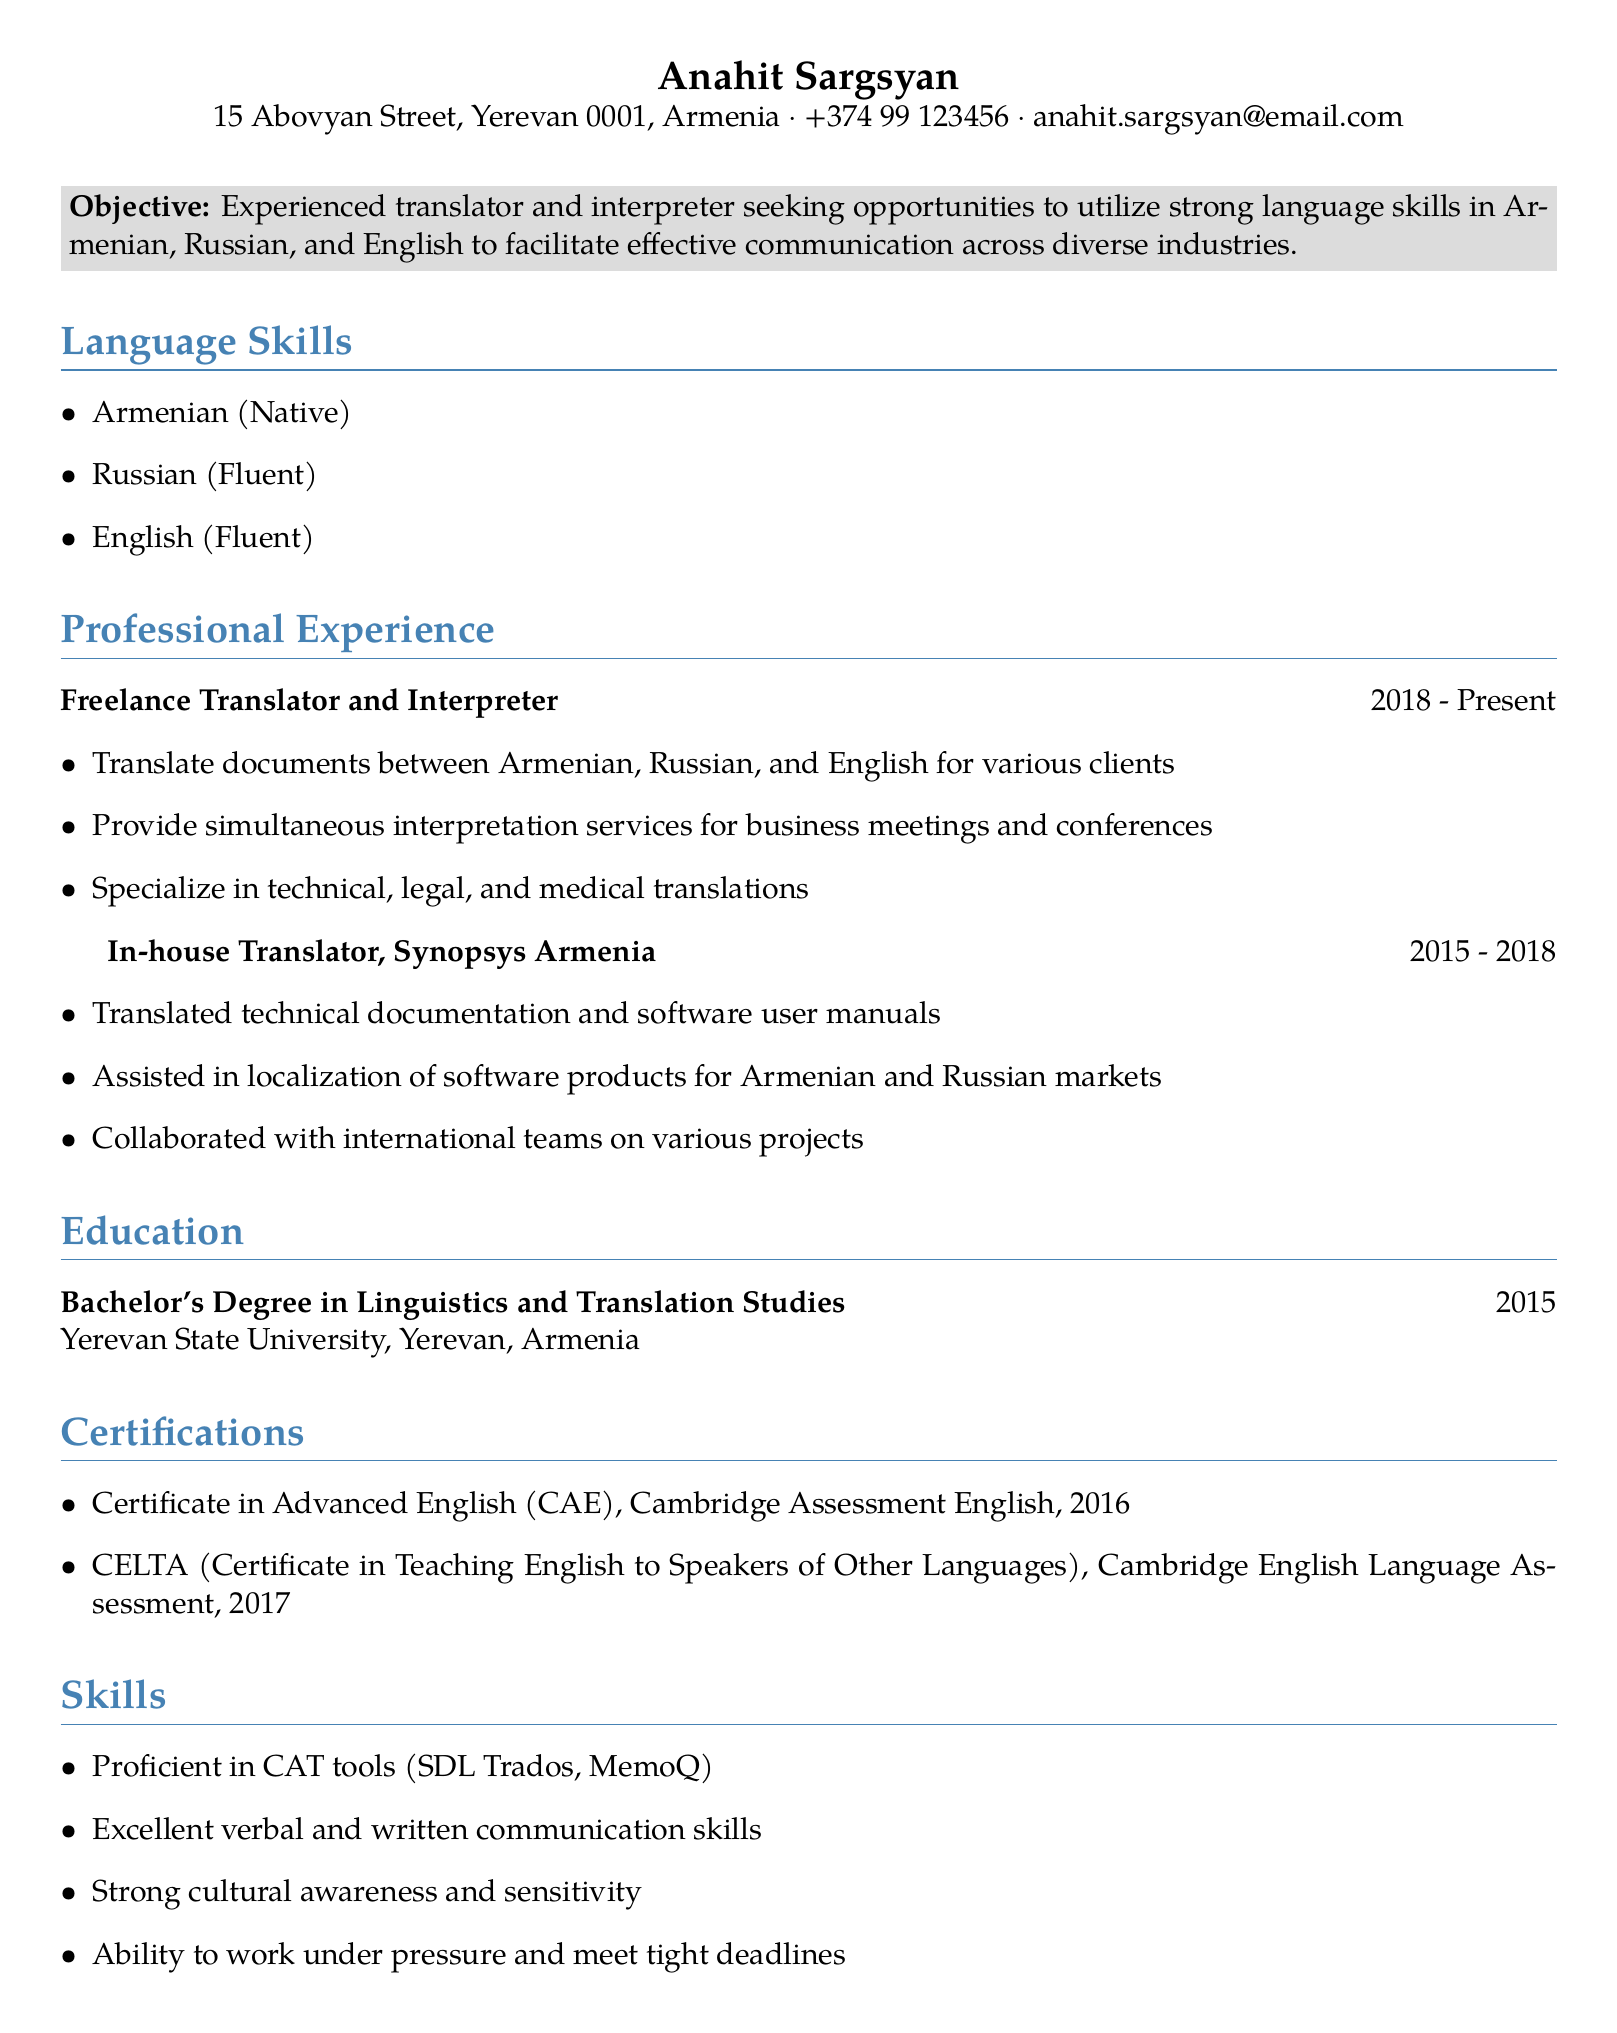What is the name of the person? The name is the first information presented in the document under personal info.
Answer: Anahit Sargsyan What degree does Anahit Sargsyan hold? The degree is listed in the education section of the CV.
Answer: Bachelor's Degree in Linguistics and Translation Studies What are Anahit Sargsyan's language proficiencies? The language skills section lists the languages along with proficiency levels.
Answer: Armenian (Native), Russian (Fluent), English (Fluent) How many years of experience does Anahit have as a freelance translator? The duration of the freelance work is given, starting from 2018 up to the present.
Answer: 5 years Which certification was obtained in 2017? The certifications section lists the names and years of certifications received.
Answer: CELTA (Certificate in Teaching English to Speakers of Other Languages) What position did Anahit hold from 2015 to 2018? The professional experience section provides job titles and corresponding years.
Answer: In-house Translator What types of translations does Anahit specialize in? The responsibilities for the freelance translator role highlight the types of translations.
Answer: Technical, legal, and medical translations Where did Anahit graduate from? The education section specifies the institution where Anahit completed her degree.
Answer: Yerevan State University What tools is Anahit proficient in? The skills section includes specific tools related to translation work.
Answer: CAT tools (SDL Trados, MemoQ) 